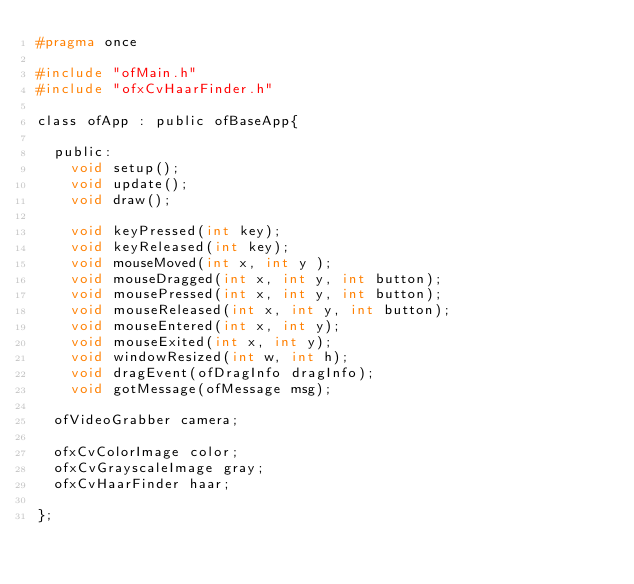<code> <loc_0><loc_0><loc_500><loc_500><_C_>#pragma once

#include "ofMain.h"
#include "ofxCvHaarFinder.h"

class ofApp : public ofBaseApp{

	public:
		void setup();
		void update();
		void draw();

		void keyPressed(int key);
		void keyReleased(int key);
		void mouseMoved(int x, int y );
		void mouseDragged(int x, int y, int button);
		void mousePressed(int x, int y, int button);
		void mouseReleased(int x, int y, int button);
		void mouseEntered(int x, int y);
		void mouseExited(int x, int y);
		void windowResized(int w, int h);
		void dragEvent(ofDragInfo dragInfo);
		void gotMessage(ofMessage msg);
  
  ofVideoGrabber camera;
  
  ofxCvColorImage color;
  ofxCvGrayscaleImage gray;
  ofxCvHaarFinder haar;
		
};
</code> 